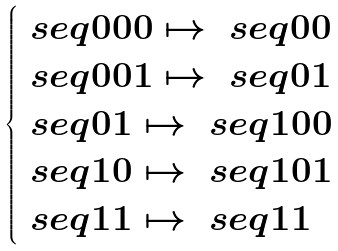Convert formula to latex. <formula><loc_0><loc_0><loc_500><loc_500>\begin{cases} \ s e q { 0 0 0 } \mapsto \ s e q { 0 0 } \\ \ s e q { 0 0 1 } \mapsto \ s e q { 0 1 } \\ \ s e q { 0 1 } \mapsto \ s e q { 1 0 0 } \\ \ s e q { 1 0 } \mapsto \ s e q { 1 0 1 } \\ \ s e q { 1 1 } \mapsto \ s e q { 1 1 } \\ \end{cases}</formula> 